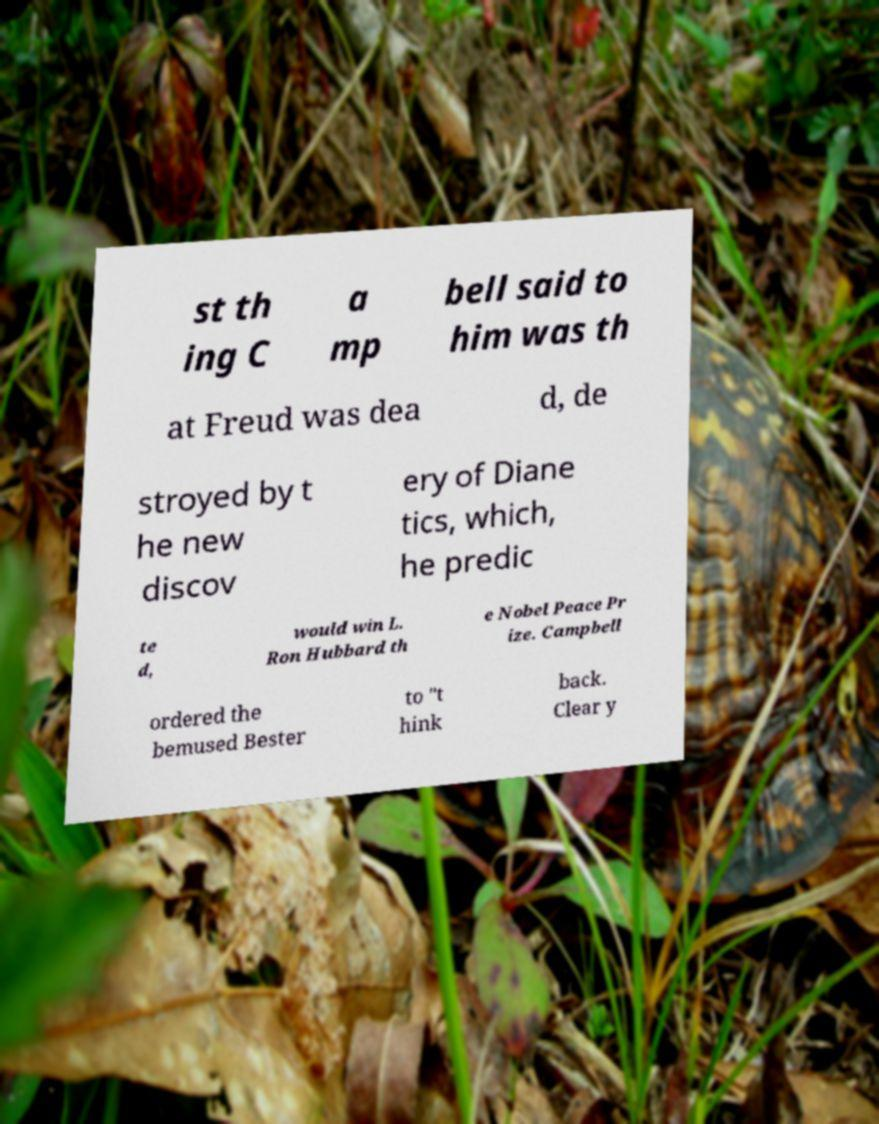For documentation purposes, I need the text within this image transcribed. Could you provide that? st th ing C a mp bell said to him was th at Freud was dea d, de stroyed by t he new discov ery of Diane tics, which, he predic te d, would win L. Ron Hubbard th e Nobel Peace Pr ize. Campbell ordered the bemused Bester to "t hink back. Clear y 